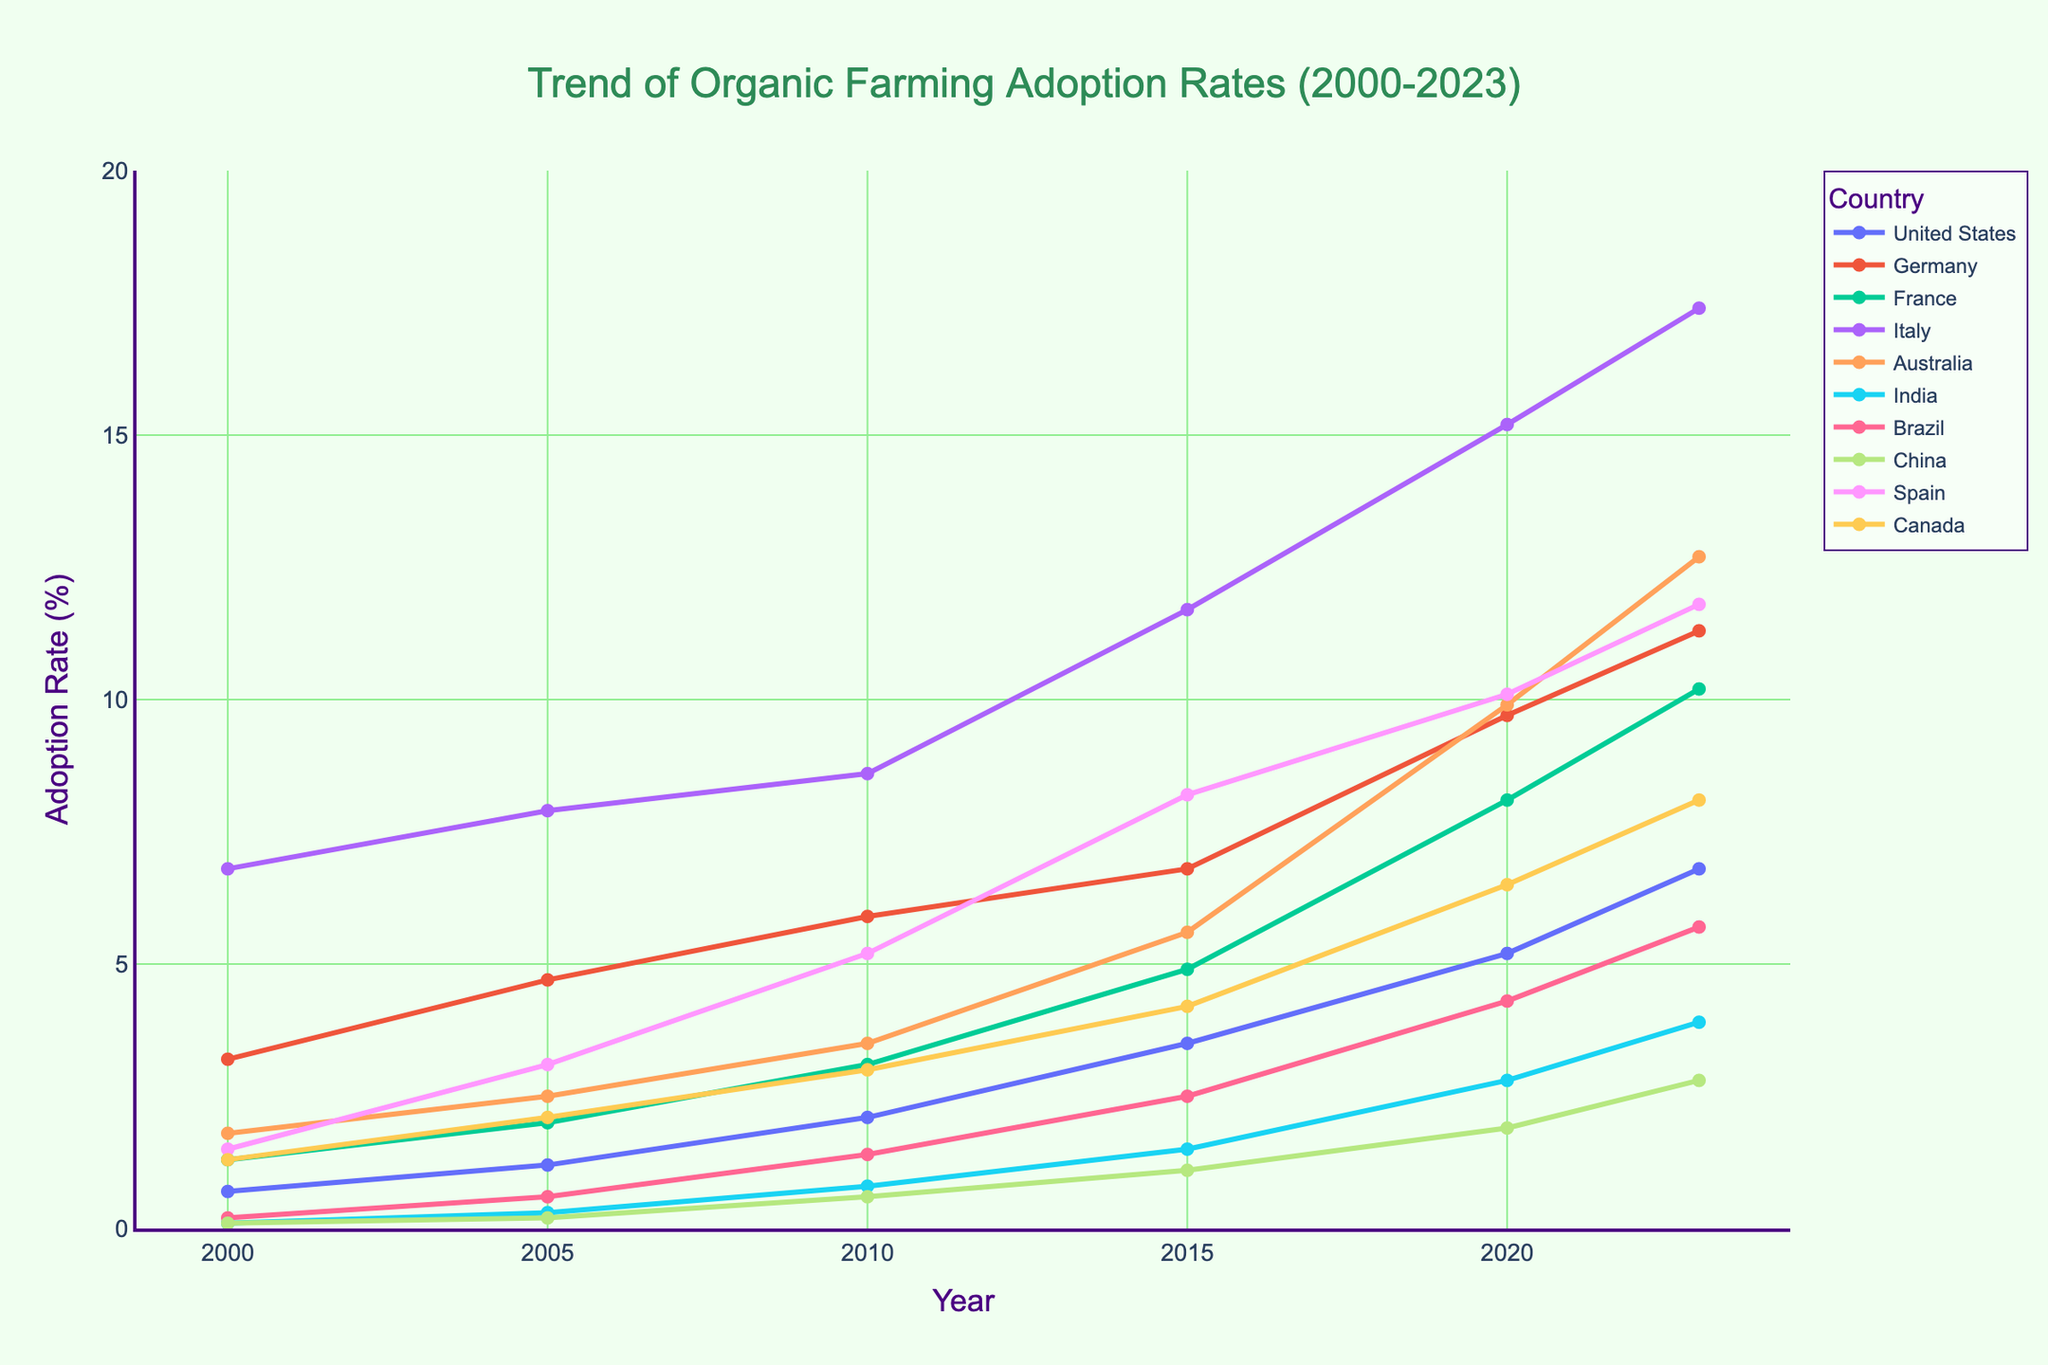What is the trend of organic farming adoption rates in the United States from 2000 to 2023? The adoption rate in the United States shows a consistent upward trend. In 2000 it was 0.7%, and by 2023 it increased to 6.8%. This indicates a growing interest and adoption of organic farming practices in the US over these years.
Answer: Increasing Which country had the highest adoption rate in 2000? To answer this, compare all the values for 2000 across countries. Italy has the highest adoption rate of 6.8% in 2000.
Answer: Italy Between France and Germany, which country witnessed a greater increase in adoption rates from 2000 to 2023? Calculate the increase for both countries: France's increase = 10.2% - 1.3% = 8.9%; Germany's increase = 11.3% - 3.2% = 8.1%. France had a greater increase in adoption rates.
Answer: France What was the adoption rate in Brazil in 2015, and how does it compare to the rate in 2023? The adoption rate in Brazil in 2015 was 2.5%, and it increased to 5.7% in 2023. Comparing these, the adoption rate in 2023 is more than double the rate in 2015.
Answer: More than double Which country had the lowest adoption rate in 2023, and what was the rate? Look at the values for 2023 across all countries. China had the lowest adoption rate in 2023 at 2.8%.
Answer: China, 2.8% How did the adoption rate in Australia change from 2000 to 2020? The adoption rate in Australia increased from 1.8% in 2000 to 9.9% in 2020. The difference is 9.9% - 1.8% = 8.1%, indicating a significant increase over these years.
Answer: Increased by 8.1% Which countries had a double-digit adoption rate by 2023, and what were their rates? Check the values for 2023 to identify countries with rates 10% or higher. The countries are Germany (11.3%), France (10.2%), Italy (17.4%), Australia (12.7%), and Spain (11.8%).
Answer: Germany, France, Italy, Australia, Spain Between 2005 and 2015, which country experienced the highest growth in adoption rates? Calculate the growth for each country over this period: United States (3.5% - 1.2% = 2.3%), Germany (6.8% - 4.7% = 2.1%), France (4.9% - 2.0% = 2.9%), Italy (11.7% - 7.9% = 3.8%), Australia (5.6% - 2.5% = 3.1%), India (1.5% - 0.3% = 1.2%), Brazil (2.5% - 0.6% = 1.9%), China (1.1% - 0.2% = 0.9%), Spain (8.2% - 3.1% = 5.1%), and Canada (4.2% - 2.1% = 2.1%). Spain had the highest growth of 5.1%.
Answer: Spain What was the general trend in adoption rates in major agricultural countries from 2000 to 2023? Overall, the trend across all major countries shows a significant increase in organic farming adoption rates from 2000 to 2023. Each country has shown progressive growth, indicating a global move towards organic farming.
Answer: Increasing globally 